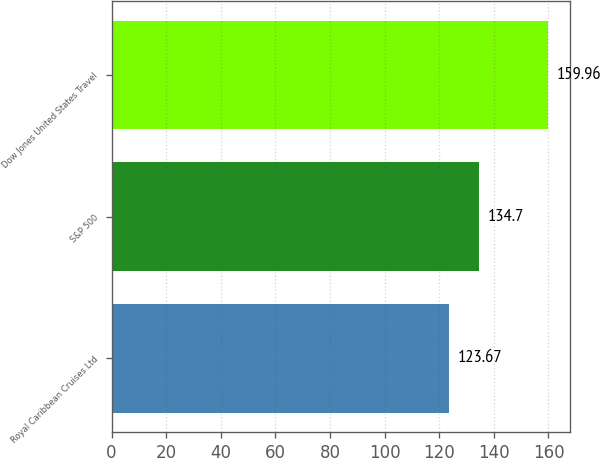Convert chart. <chart><loc_0><loc_0><loc_500><loc_500><bar_chart><fcel>Royal Caribbean Cruises Ltd<fcel>S&P 500<fcel>Dow Jones United States Travel<nl><fcel>123.67<fcel>134.7<fcel>159.96<nl></chart> 